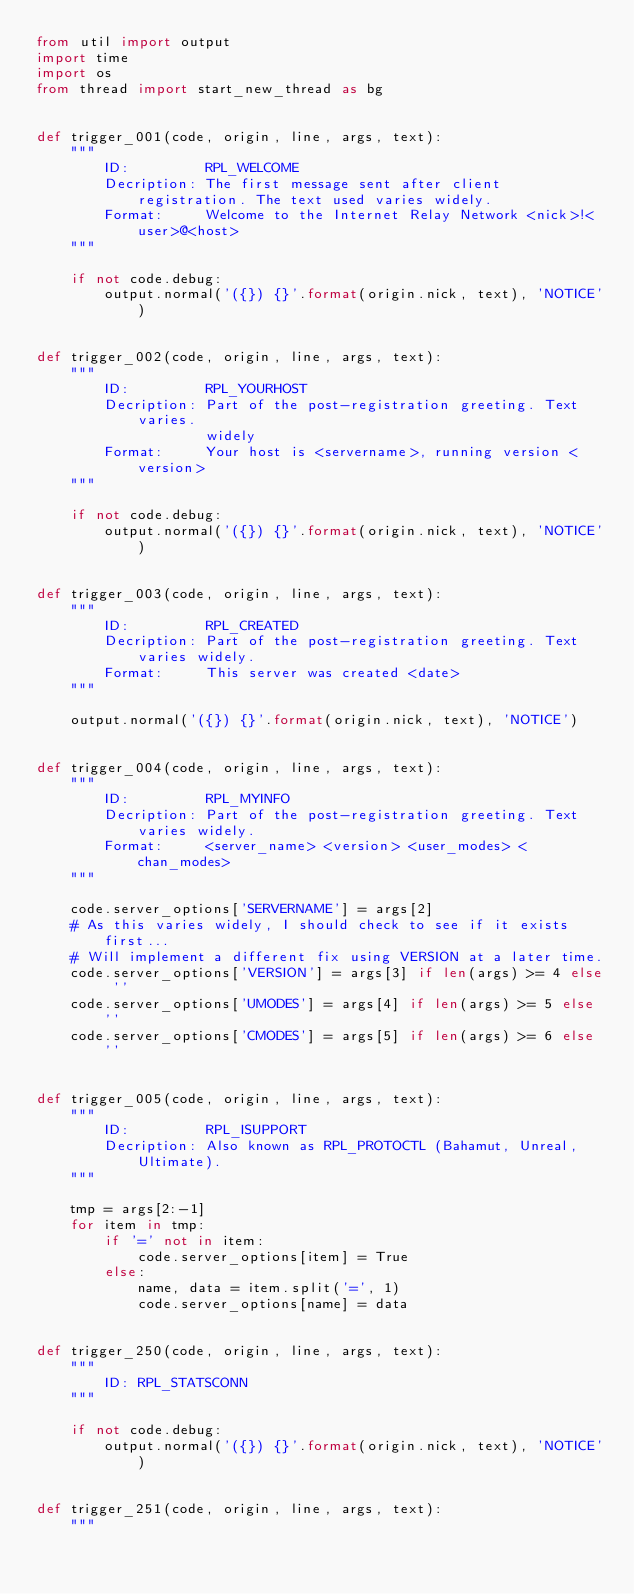Convert code to text. <code><loc_0><loc_0><loc_500><loc_500><_Python_>from util import output
import time
import os
from thread import start_new_thread as bg


def trigger_001(code, origin, line, args, text):
    """
        ID:         RPL_WELCOME
        Decription: The first message sent after client registration. The text used varies widely.
        Format:     Welcome to the Internet Relay Network <nick>!<user>@<host>
    """

    if not code.debug:
        output.normal('({}) {}'.format(origin.nick, text), 'NOTICE')


def trigger_002(code, origin, line, args, text):
    """
        ID:         RPL_YOURHOST
        Decription: Part of the post-registration greeting. Text varies.
                    widely
        Format:     Your host is <servername>, running version <version>
    """

    if not code.debug:
        output.normal('({}) {}'.format(origin.nick, text), 'NOTICE')


def trigger_003(code, origin, line, args, text):
    """
        ID:         RPL_CREATED
        Decription: Part of the post-registration greeting. Text varies widely.
        Format:     This server was created <date>
    """

    output.normal('({}) {}'.format(origin.nick, text), 'NOTICE')


def trigger_004(code, origin, line, args, text):
    """
        ID:         RPL_MYINFO
        Decription: Part of the post-registration greeting. Text varies widely.
        Format:     <server_name> <version> <user_modes> <chan_modes>
    """

    code.server_options['SERVERNAME'] = args[2]
    # As this varies widely, I should check to see if it exists first...
    # Will implement a different fix using VERSION at a later time.
    code.server_options['VERSION'] = args[3] if len(args) >= 4 else ''
    code.server_options['UMODES'] = args[4] if len(args) >= 5 else ''
    code.server_options['CMODES'] = args[5] if len(args) >= 6 else ''


def trigger_005(code, origin, line, args, text):
    """
        ID:         RPL_ISUPPORT
        Decription: Also known as RPL_PROTOCTL (Bahamut, Unreal, Ultimate).
    """

    tmp = args[2:-1]
    for item in tmp:
        if '=' not in item:
            code.server_options[item] = True
        else:
            name, data = item.split('=', 1)
            code.server_options[name] = data


def trigger_250(code, origin, line, args, text):
    """
        ID: RPL_STATSCONN
    """

    if not code.debug:
        output.normal('({}) {}'.format(origin.nick, text), 'NOTICE')


def trigger_251(code, origin, line, args, text):
    """</code> 